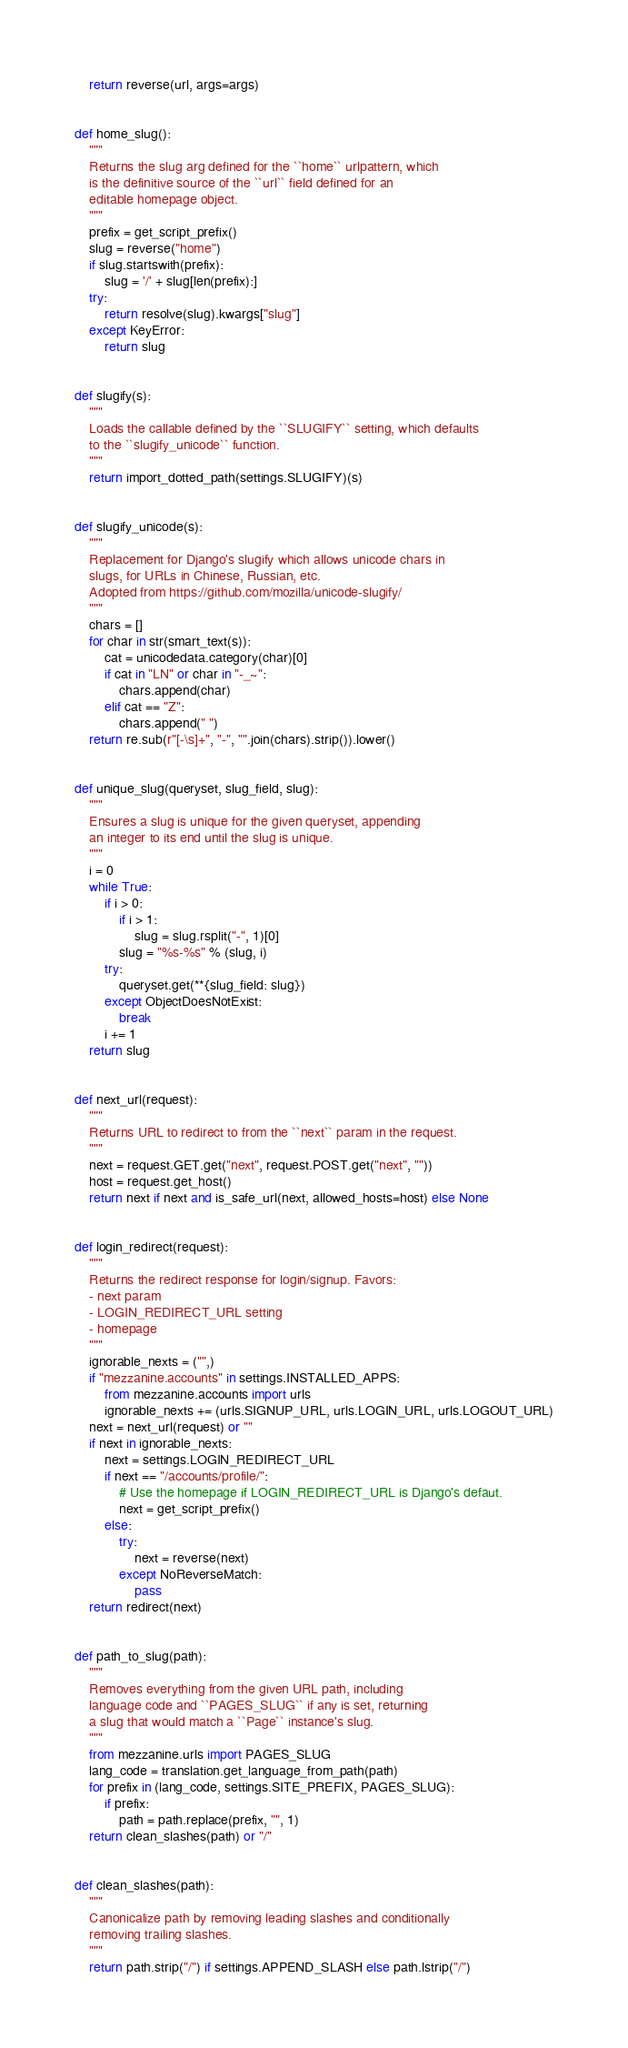<code> <loc_0><loc_0><loc_500><loc_500><_Python_>    return reverse(url, args=args)


def home_slug():
    """
    Returns the slug arg defined for the ``home`` urlpattern, which
    is the definitive source of the ``url`` field defined for an
    editable homepage object.
    """
    prefix = get_script_prefix()
    slug = reverse("home")
    if slug.startswith(prefix):
        slug = '/' + slug[len(prefix):]
    try:
        return resolve(slug).kwargs["slug"]
    except KeyError:
        return slug


def slugify(s):
    """
    Loads the callable defined by the ``SLUGIFY`` setting, which defaults
    to the ``slugify_unicode`` function.
    """
    return import_dotted_path(settings.SLUGIFY)(s)


def slugify_unicode(s):
    """
    Replacement for Django's slugify which allows unicode chars in
    slugs, for URLs in Chinese, Russian, etc.
    Adopted from https://github.com/mozilla/unicode-slugify/
    """
    chars = []
    for char in str(smart_text(s)):
        cat = unicodedata.category(char)[0]
        if cat in "LN" or char in "-_~":
            chars.append(char)
        elif cat == "Z":
            chars.append(" ")
    return re.sub(r"[-\s]+", "-", "".join(chars).strip()).lower()


def unique_slug(queryset, slug_field, slug):
    """
    Ensures a slug is unique for the given queryset, appending
    an integer to its end until the slug is unique.
    """
    i = 0
    while True:
        if i > 0:
            if i > 1:
                slug = slug.rsplit("-", 1)[0]
            slug = "%s-%s" % (slug, i)
        try:
            queryset.get(**{slug_field: slug})
        except ObjectDoesNotExist:
            break
        i += 1
    return slug


def next_url(request):
    """
    Returns URL to redirect to from the ``next`` param in the request.
    """
    next = request.GET.get("next", request.POST.get("next", ""))
    host = request.get_host()
    return next if next and is_safe_url(next, allowed_hosts=host) else None


def login_redirect(request):
    """
    Returns the redirect response for login/signup. Favors:
    - next param
    - LOGIN_REDIRECT_URL setting
    - homepage
    """
    ignorable_nexts = ("",)
    if "mezzanine.accounts" in settings.INSTALLED_APPS:
        from mezzanine.accounts import urls
        ignorable_nexts += (urls.SIGNUP_URL, urls.LOGIN_URL, urls.LOGOUT_URL)
    next = next_url(request) or ""
    if next in ignorable_nexts:
        next = settings.LOGIN_REDIRECT_URL
        if next == "/accounts/profile/":
            # Use the homepage if LOGIN_REDIRECT_URL is Django's defaut.
            next = get_script_prefix()
        else:
            try:
                next = reverse(next)
            except NoReverseMatch:
                pass
    return redirect(next)


def path_to_slug(path):
    """
    Removes everything from the given URL path, including
    language code and ``PAGES_SLUG`` if any is set, returning
    a slug that would match a ``Page`` instance's slug.
    """
    from mezzanine.urls import PAGES_SLUG
    lang_code = translation.get_language_from_path(path)
    for prefix in (lang_code, settings.SITE_PREFIX, PAGES_SLUG):
        if prefix:
            path = path.replace(prefix, "", 1)
    return clean_slashes(path) or "/"


def clean_slashes(path):
    """
    Canonicalize path by removing leading slashes and conditionally
    removing trailing slashes.
    """
    return path.strip("/") if settings.APPEND_SLASH else path.lstrip("/")
</code> 